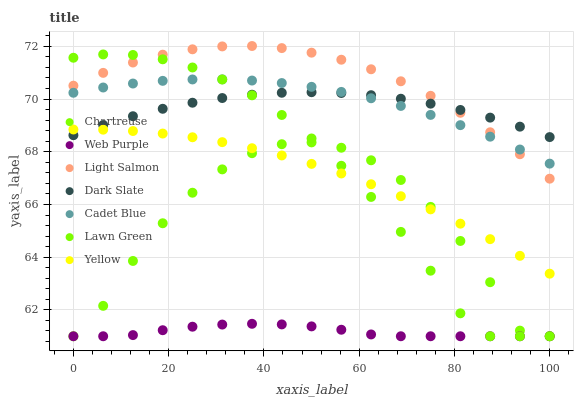Does Web Purple have the minimum area under the curve?
Answer yes or no. Yes. Does Light Salmon have the maximum area under the curve?
Answer yes or no. Yes. Does Cadet Blue have the minimum area under the curve?
Answer yes or no. No. Does Cadet Blue have the maximum area under the curve?
Answer yes or no. No. Is Yellow the smoothest?
Answer yes or no. Yes. Is Chartreuse the roughest?
Answer yes or no. Yes. Is Light Salmon the smoothest?
Answer yes or no. No. Is Light Salmon the roughest?
Answer yes or no. No. Does Lawn Green have the lowest value?
Answer yes or no. Yes. Does Light Salmon have the lowest value?
Answer yes or no. No. Does Light Salmon have the highest value?
Answer yes or no. Yes. Does Cadet Blue have the highest value?
Answer yes or no. No. Is Web Purple less than Cadet Blue?
Answer yes or no. Yes. Is Cadet Blue greater than Yellow?
Answer yes or no. Yes. Does Lawn Green intersect Yellow?
Answer yes or no. Yes. Is Lawn Green less than Yellow?
Answer yes or no. No. Is Lawn Green greater than Yellow?
Answer yes or no. No. Does Web Purple intersect Cadet Blue?
Answer yes or no. No. 